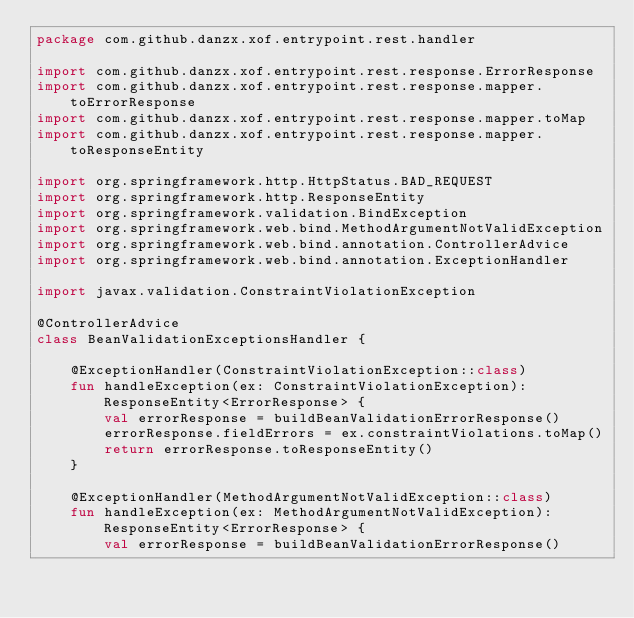<code> <loc_0><loc_0><loc_500><loc_500><_Kotlin_>package com.github.danzx.xof.entrypoint.rest.handler

import com.github.danzx.xof.entrypoint.rest.response.ErrorResponse
import com.github.danzx.xof.entrypoint.rest.response.mapper.toErrorResponse
import com.github.danzx.xof.entrypoint.rest.response.mapper.toMap
import com.github.danzx.xof.entrypoint.rest.response.mapper.toResponseEntity

import org.springframework.http.HttpStatus.BAD_REQUEST
import org.springframework.http.ResponseEntity
import org.springframework.validation.BindException
import org.springframework.web.bind.MethodArgumentNotValidException
import org.springframework.web.bind.annotation.ControllerAdvice
import org.springframework.web.bind.annotation.ExceptionHandler

import javax.validation.ConstraintViolationException

@ControllerAdvice
class BeanValidationExceptionsHandler {

    @ExceptionHandler(ConstraintViolationException::class)
    fun handleException(ex: ConstraintViolationException): ResponseEntity<ErrorResponse> {
        val errorResponse = buildBeanValidationErrorResponse()
        errorResponse.fieldErrors = ex.constraintViolations.toMap()
        return errorResponse.toResponseEntity()
    }

    @ExceptionHandler(MethodArgumentNotValidException::class)
    fun handleException(ex: MethodArgumentNotValidException): ResponseEntity<ErrorResponse> {
        val errorResponse = buildBeanValidationErrorResponse()</code> 